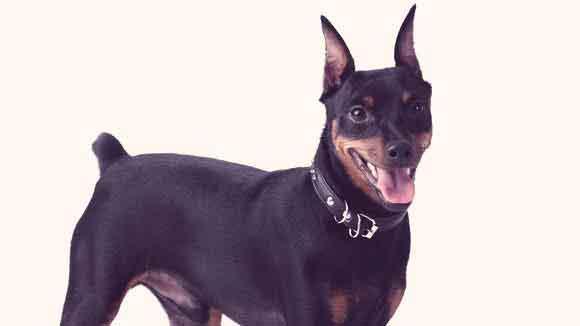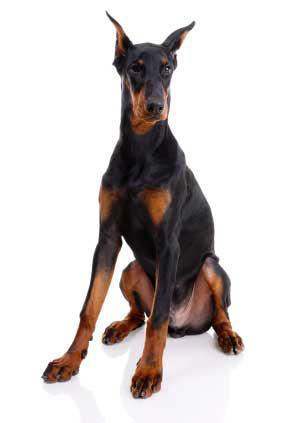The first image is the image on the left, the second image is the image on the right. Assess this claim about the two images: "More than one doberman is sitting.". Correct or not? Answer yes or no. No. The first image is the image on the left, the second image is the image on the right. For the images displayed, is the sentence "The left image shows a doberman wearing a collar, and the right image shows a doberman sitting upright without a collar on." factually correct? Answer yes or no. Yes. 